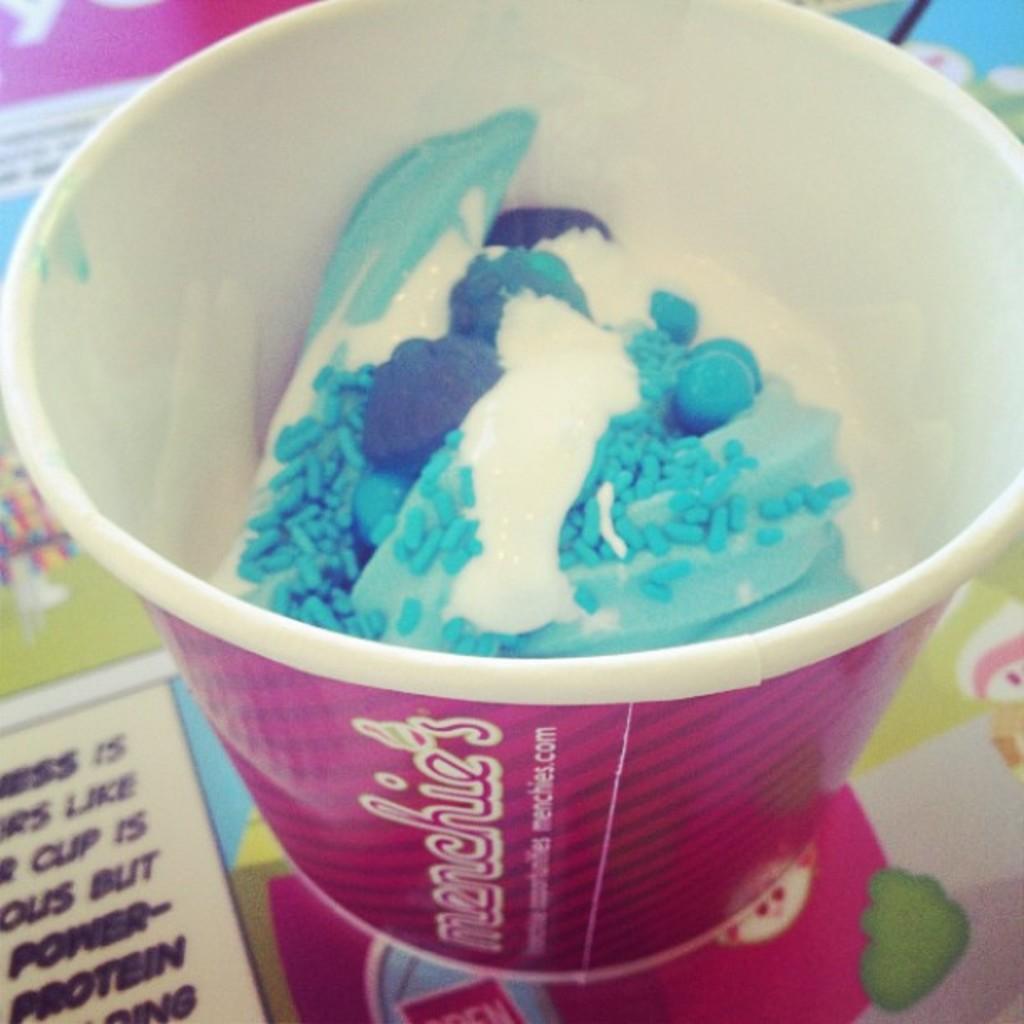Describe this image in one or two sentences. In this image I can see some ice cream in a cup. On the cup I can see something written on it. This cup is pink in color. 